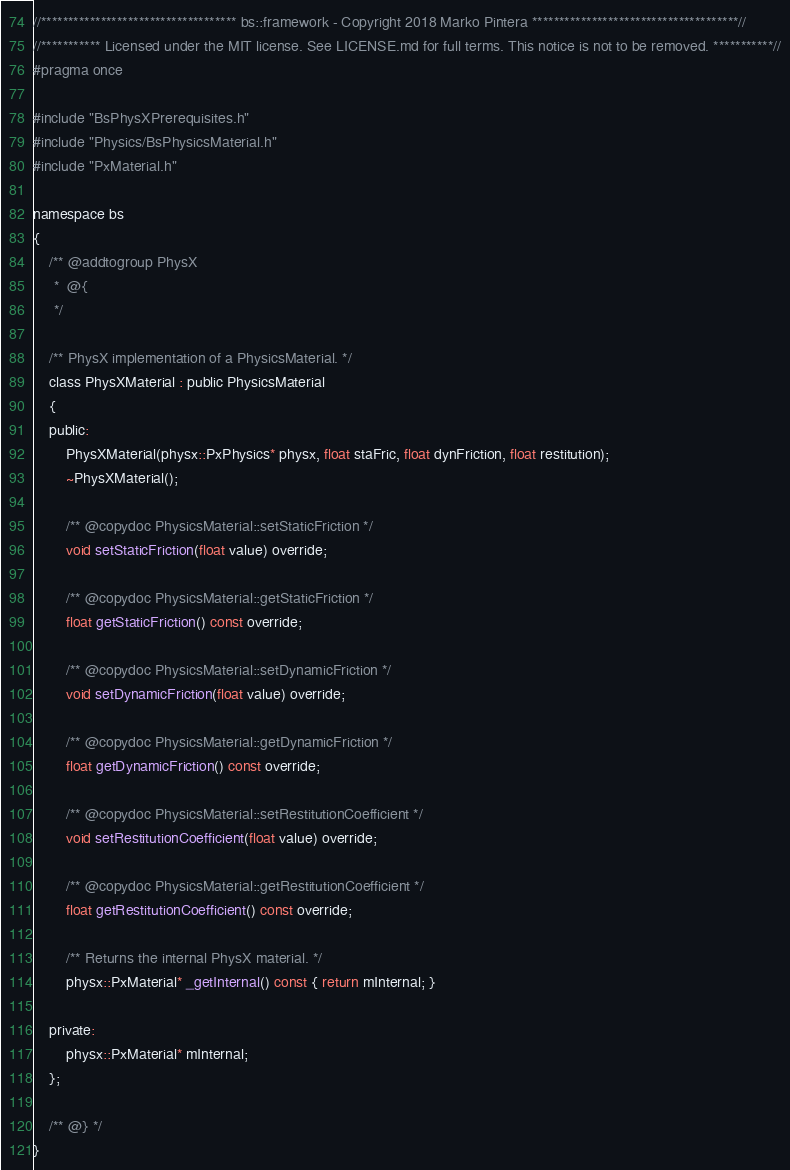<code> <loc_0><loc_0><loc_500><loc_500><_C_>//************************************ bs::framework - Copyright 2018 Marko Pintera **************************************//
//*********** Licensed under the MIT license. See LICENSE.md for full terms. This notice is not to be removed. ***********//
#pragma once

#include "BsPhysXPrerequisites.h"
#include "Physics/BsPhysicsMaterial.h"
#include "PxMaterial.h"

namespace bs
{
	/** @addtogroup PhysX
	 *  @{
	 */

	/** PhysX implementation of a PhysicsMaterial. */
	class PhysXMaterial : public PhysicsMaterial
	{
	public:
		PhysXMaterial(physx::PxPhysics* physx, float staFric, float dynFriction, float restitution);
		~PhysXMaterial();

		/** @copydoc PhysicsMaterial::setStaticFriction */
		void setStaticFriction(float value) override;

		/** @copydoc PhysicsMaterial::getStaticFriction */
		float getStaticFriction() const override;

		/** @copydoc PhysicsMaterial::setDynamicFriction */
		void setDynamicFriction(float value) override;

		/** @copydoc PhysicsMaterial::getDynamicFriction */
		float getDynamicFriction() const override;

		/** @copydoc PhysicsMaterial::setRestitutionCoefficient */
		void setRestitutionCoefficient(float value) override;

		/** @copydoc PhysicsMaterial::getRestitutionCoefficient */
		float getRestitutionCoefficient() const override;

		/** Returns the internal PhysX material. */
		physx::PxMaterial* _getInternal() const { return mInternal; }

	private:
		physx::PxMaterial* mInternal;
	};

	/** @} */
}
</code> 